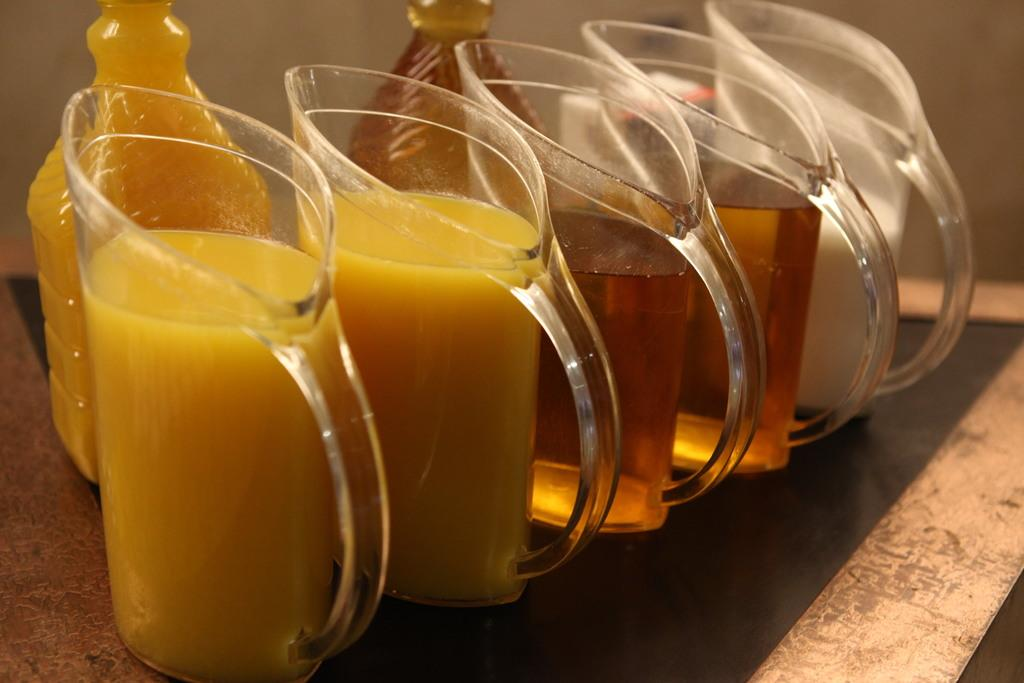What type of containers are visible in the image? There are jugs with liquid items and two glass bottles in the image. Where are the jugs and bottles located? The jugs and bottles are placed on a table. Can you describe the background of the image? The background of the image appears blurry. What is the price of the expansion pack for the game in the image? There is no game or expansion pack present in the image; it features jugs, bottles, and a table. 